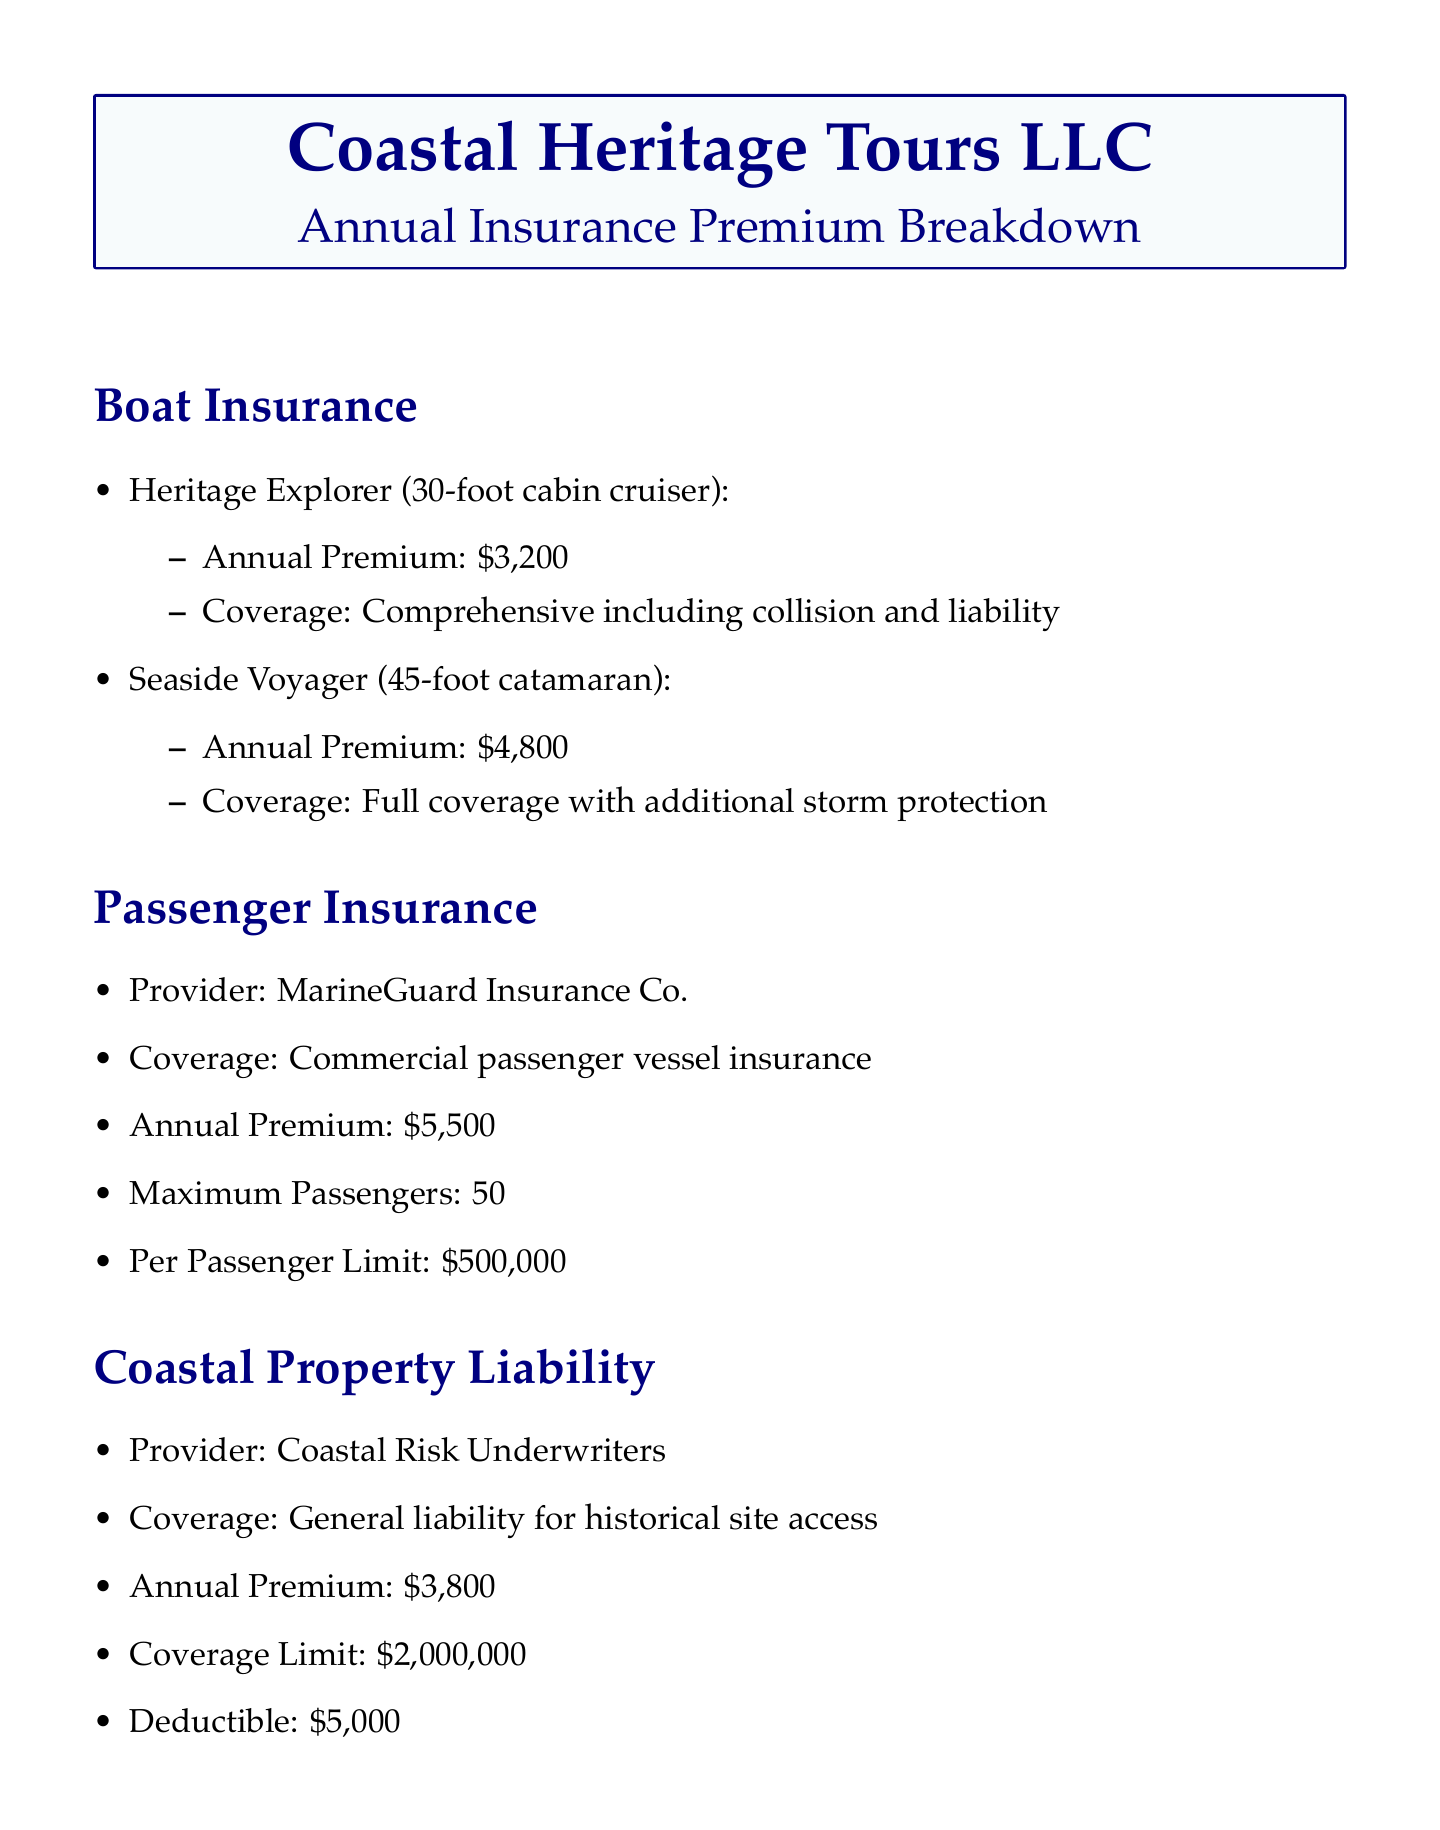What is the annual premium for Heritage Explorer? The annual premium for the Heritage Explorer (30-foot cabin cruiser) is located in the boat insurance section of the document.
Answer: $3,200 What type of coverage does Seaside Voyager have? The document specifies that the Seaside Voyager (45-foot catamaran) has full coverage with additional storm protection under the boat insurance section.
Answer: Full coverage with additional storm protection Who is the provider for passenger insurance? The document states that MarineGuard Insurance Co. is the provider for passenger insurance.
Answer: MarineGuard Insurance Co What is the coverage limit for coastal property liability? The coverage limit for coastal property liability is detailed in that section of the document, indicating how much financial coverage is provided.
Answer: $2,000,000 What is the total annual premium for all insurances? The total annual premium is summarized in a separate box at the end of the document, which provides the overall financial obligation for the year.
Answer: $21,000 What discount was applied for bundling policies? The document includes a note about discounts, specifically indicating the percentage that was applied due to bundling.
Answer: 10% What is the deductible for coastal property liability? The deductible amount for coastal property liability is noted in that section of the document and is important for understanding financial responsibility in claims.
Answer: $5,000 How many maximum passengers does the passenger insurance cover? The passenger insurance section specifies how many maximum passengers can be covered, which is key information for tour operations.
Answer: 50 What is the annual premium for Workers' Compensation? The additional coverages section provides the annual premium amount specifically for Workers' Compensation, which is part of the overall insurance coverage.
Answer: $2,200 